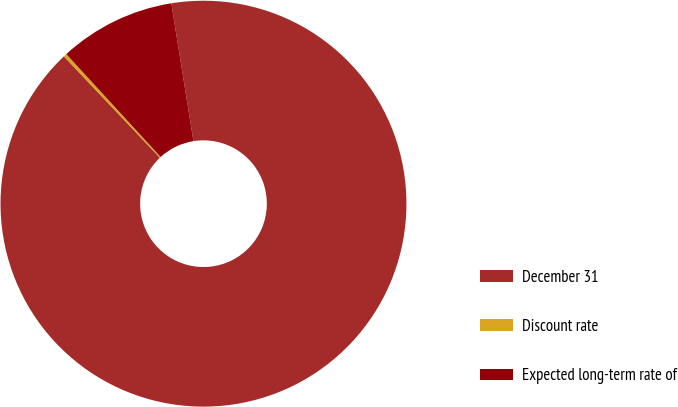<chart> <loc_0><loc_0><loc_500><loc_500><pie_chart><fcel>December 31<fcel>Discount rate<fcel>Expected long-term rate of<nl><fcel>90.46%<fcel>0.26%<fcel>9.28%<nl></chart> 